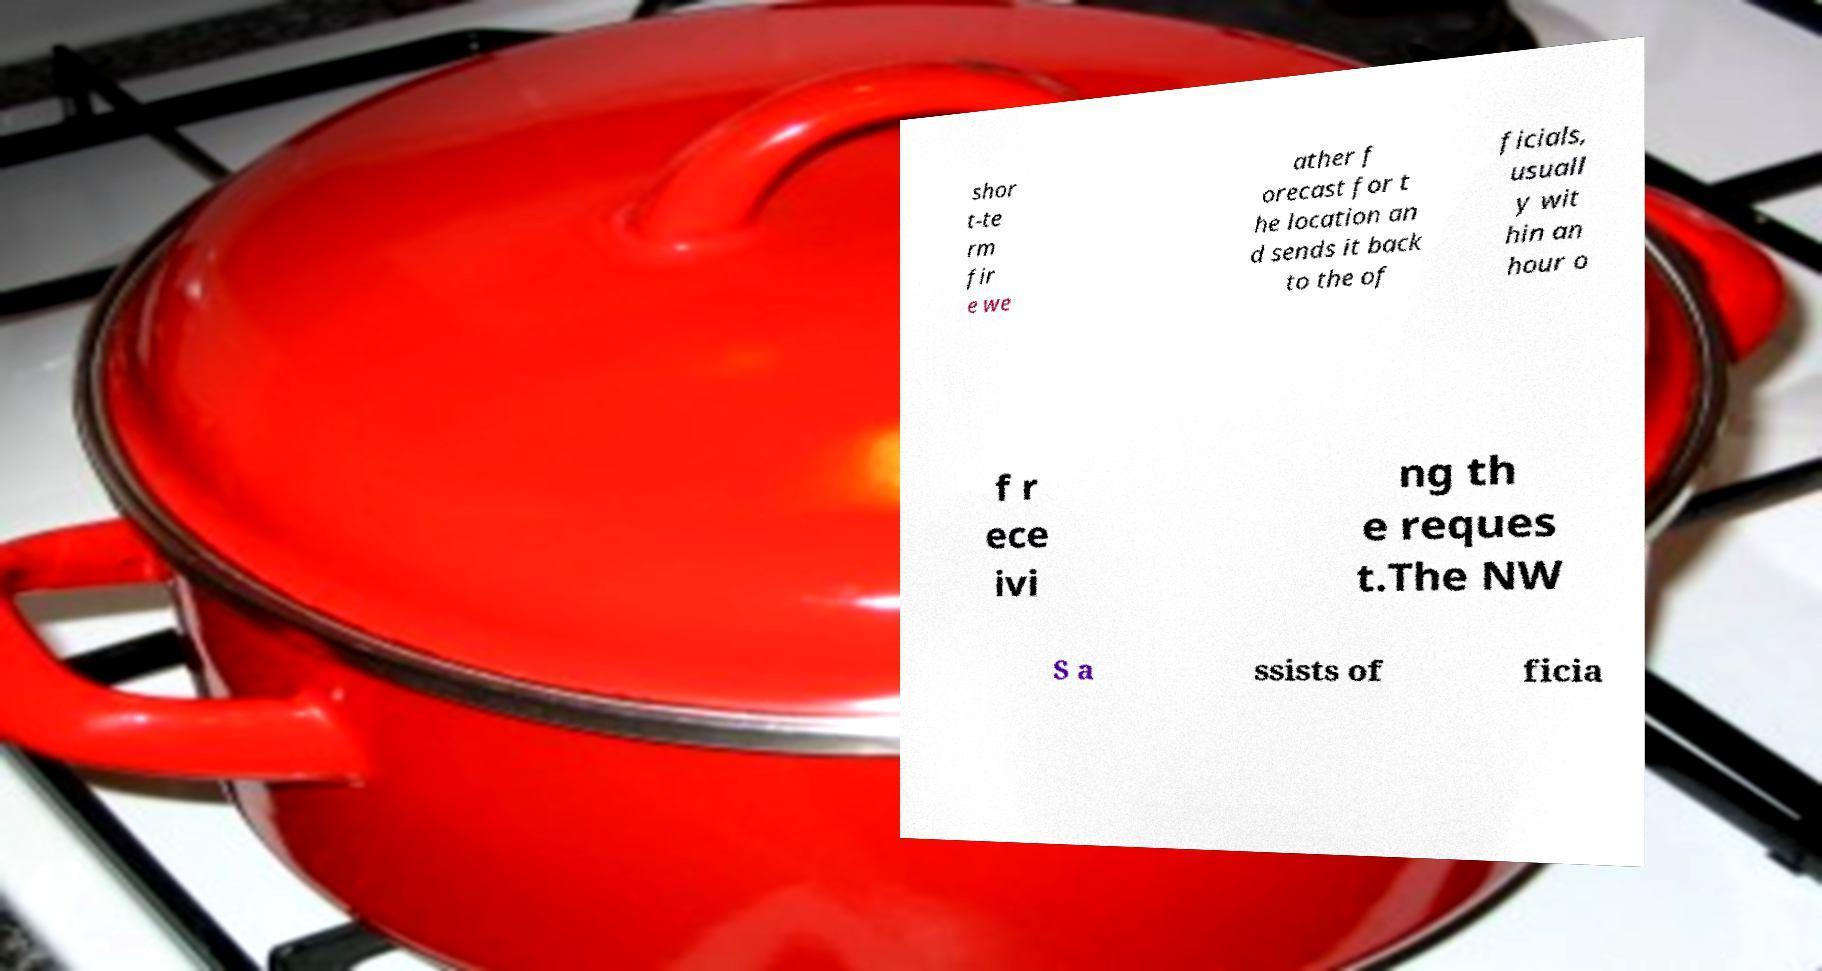What messages or text are displayed in this image? I need them in a readable, typed format. shor t-te rm fir e we ather f orecast for t he location an d sends it back to the of ficials, usuall y wit hin an hour o f r ece ivi ng th e reques t.The NW S a ssists of ficia 